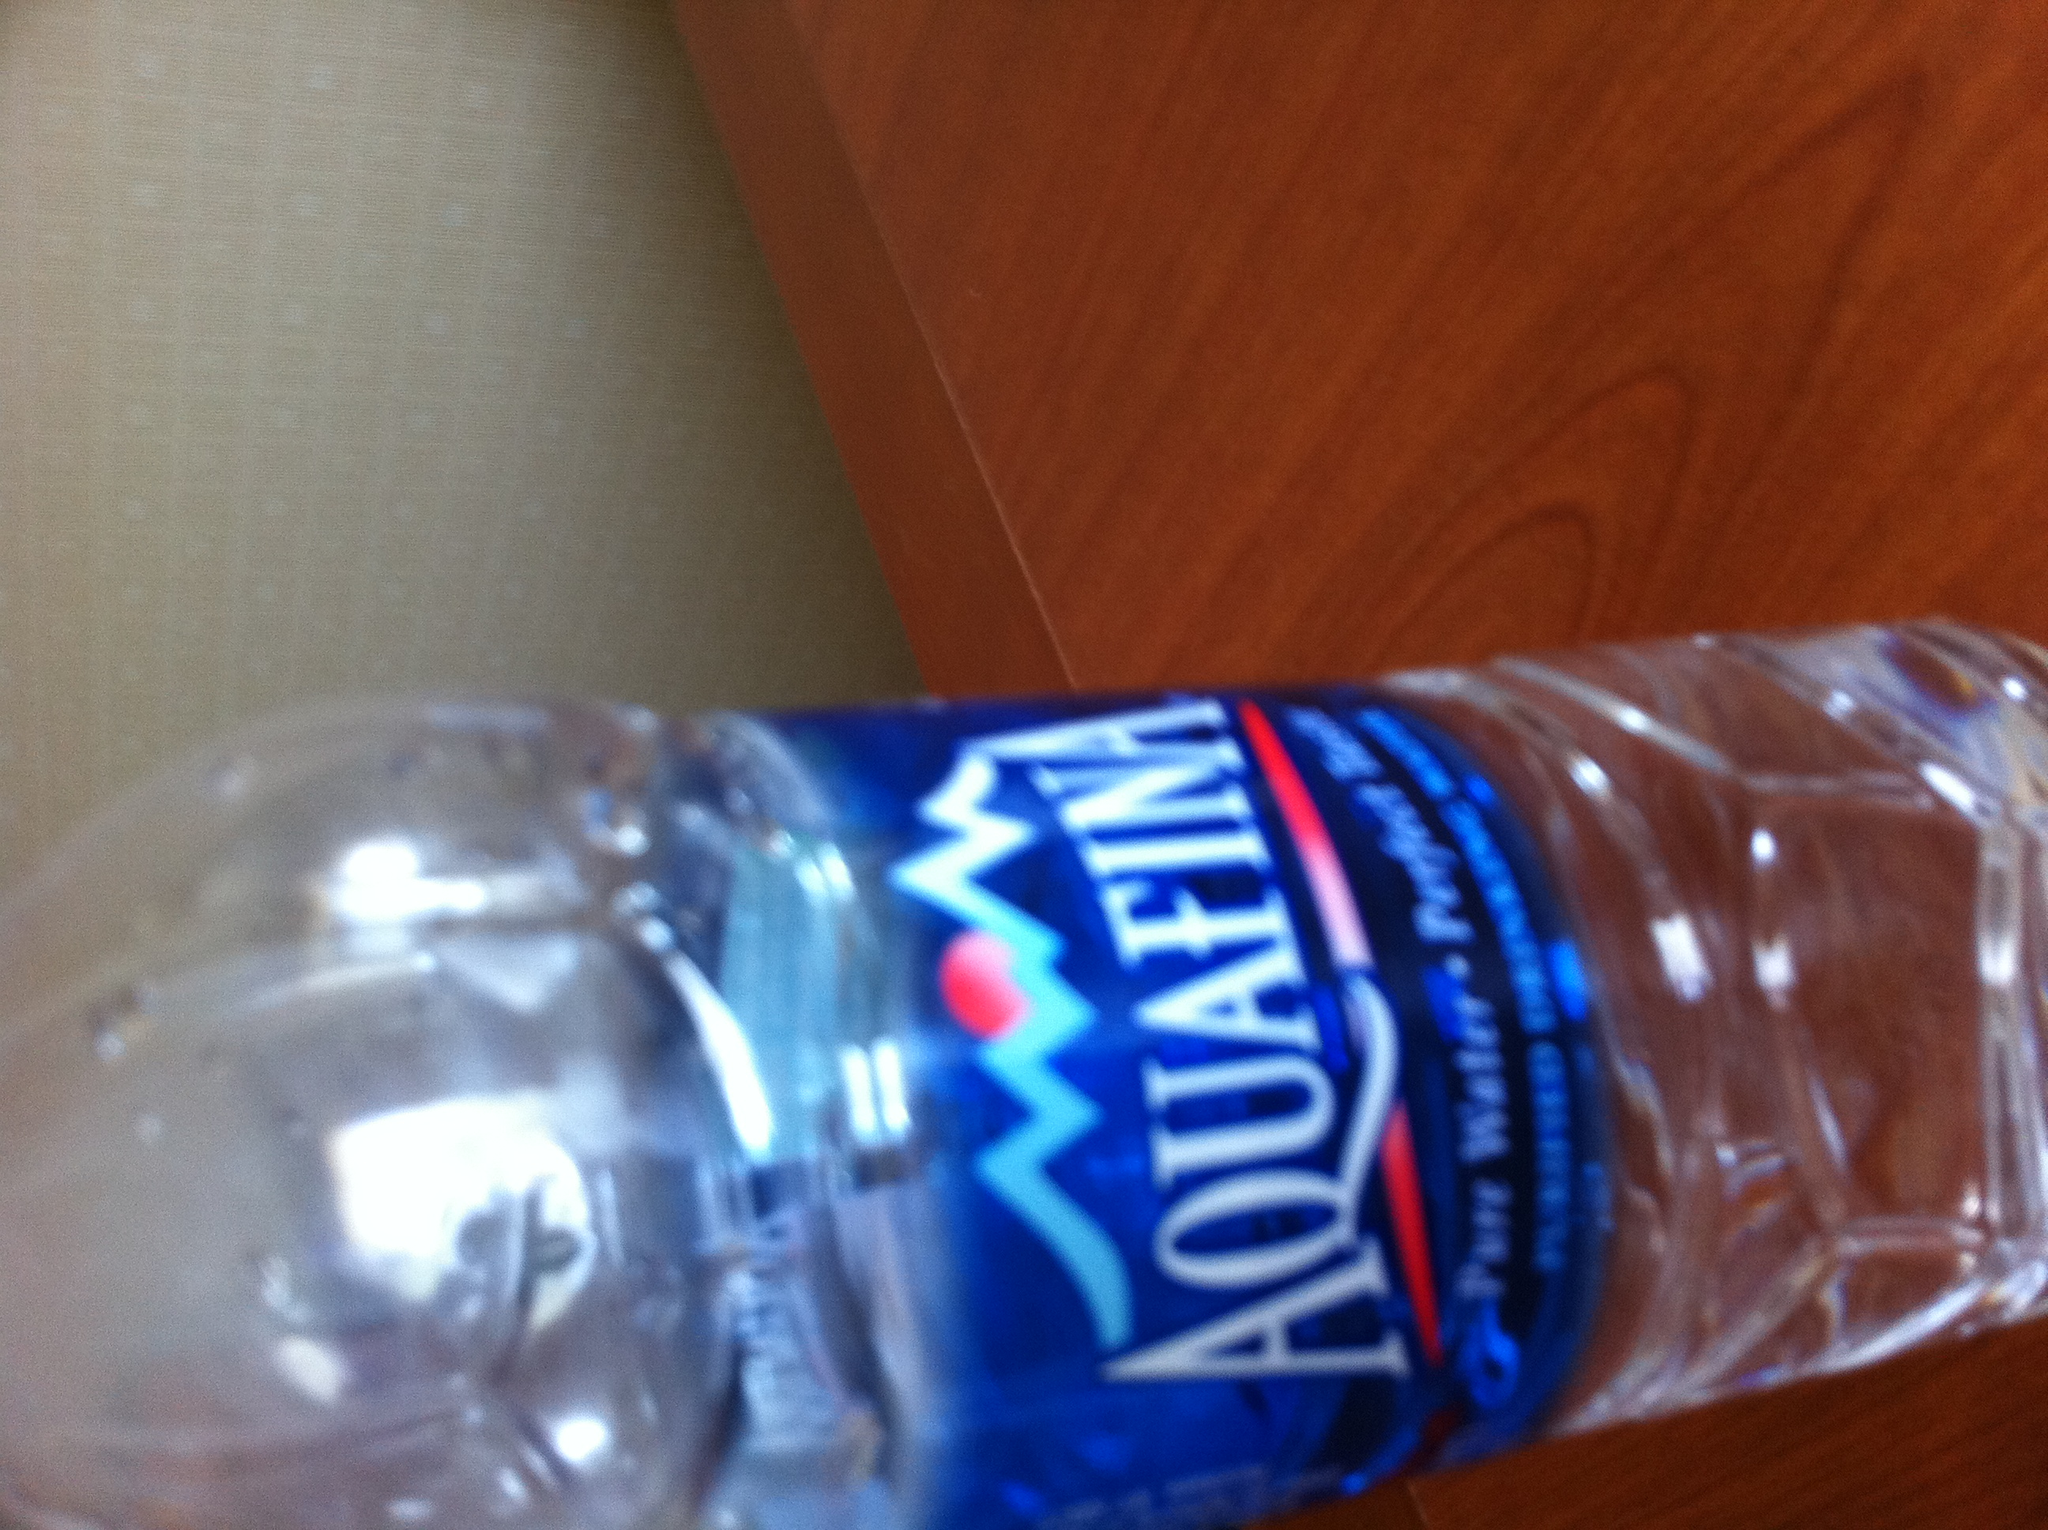Is this size of bottled water convenient for travel? Yes, the bottle depicted appears to be a smaller, personal size which is convenient for carrying in a bag or car cup holder, making it ideal for on-the-go hydration. 